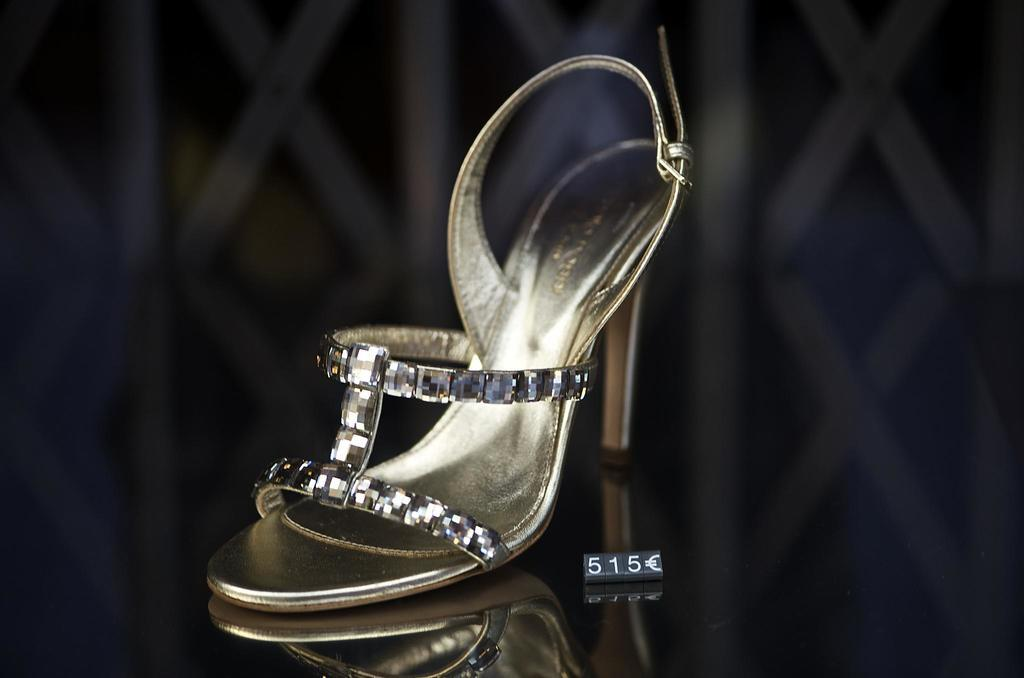What type of footwear is visible in the image? There is a sandal placed on a surface in the image. What else can be seen in the image besides the sandal? There is a board with numbers in the image. What is the name of the committee that is meeting in the image? There is no committee meeting in the image; it only features a sandal and a board with numbers. 